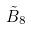<formula> <loc_0><loc_0><loc_500><loc_500>\tilde { B } _ { 8 }</formula> 